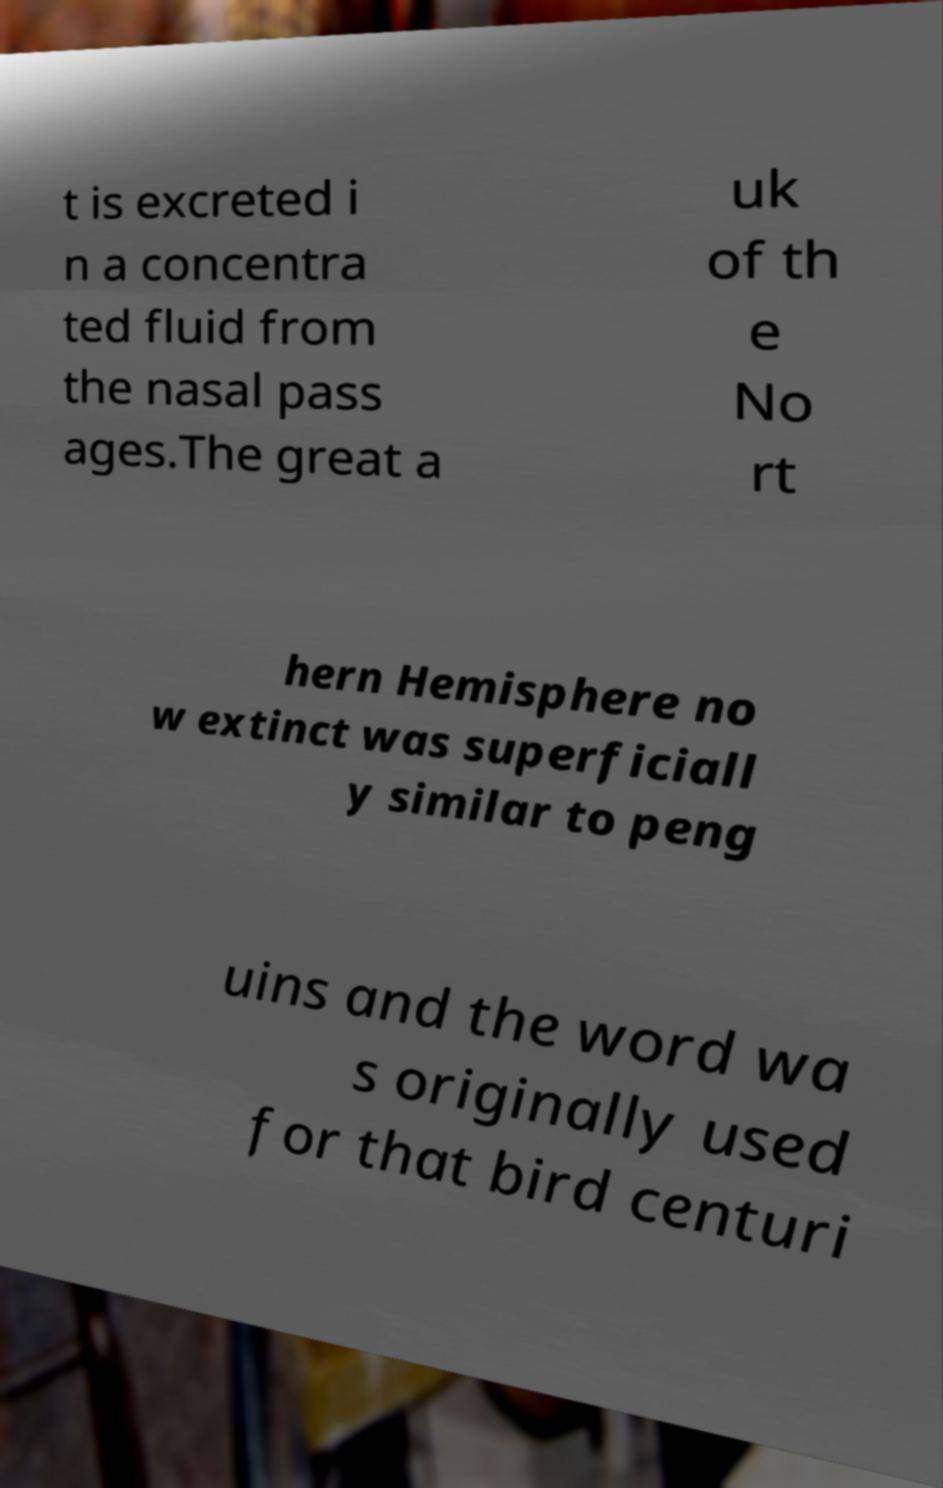Could you extract and type out the text from this image? t is excreted i n a concentra ted fluid from the nasal pass ages.The great a uk of th e No rt hern Hemisphere no w extinct was superficiall y similar to peng uins and the word wa s originally used for that bird centuri 